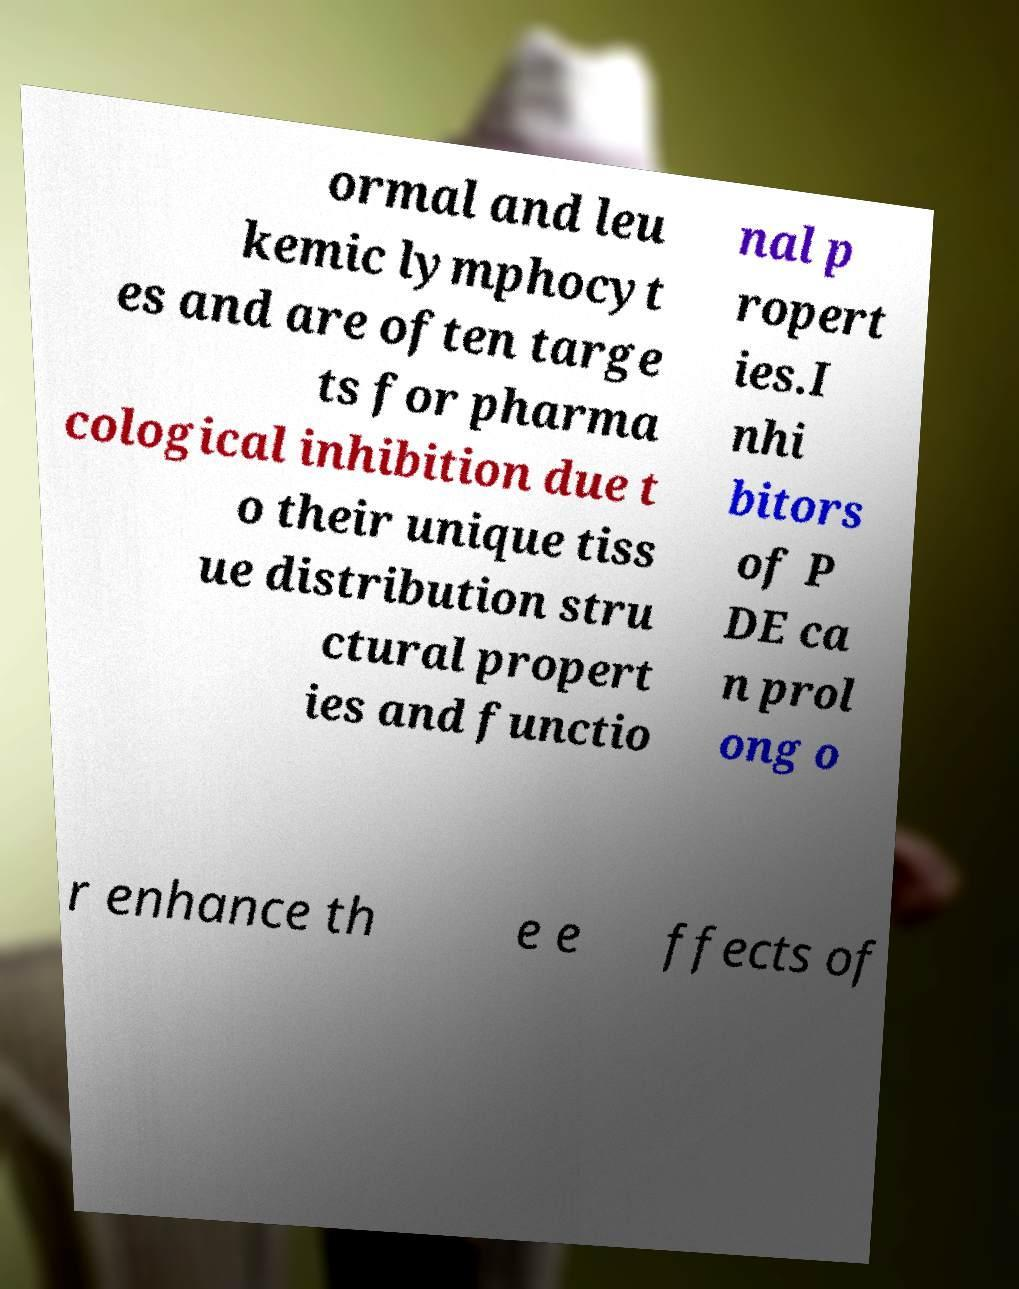Could you extract and type out the text from this image? ormal and leu kemic lymphocyt es and are often targe ts for pharma cological inhibition due t o their unique tiss ue distribution stru ctural propert ies and functio nal p ropert ies.I nhi bitors of P DE ca n prol ong o r enhance th e e ffects of 